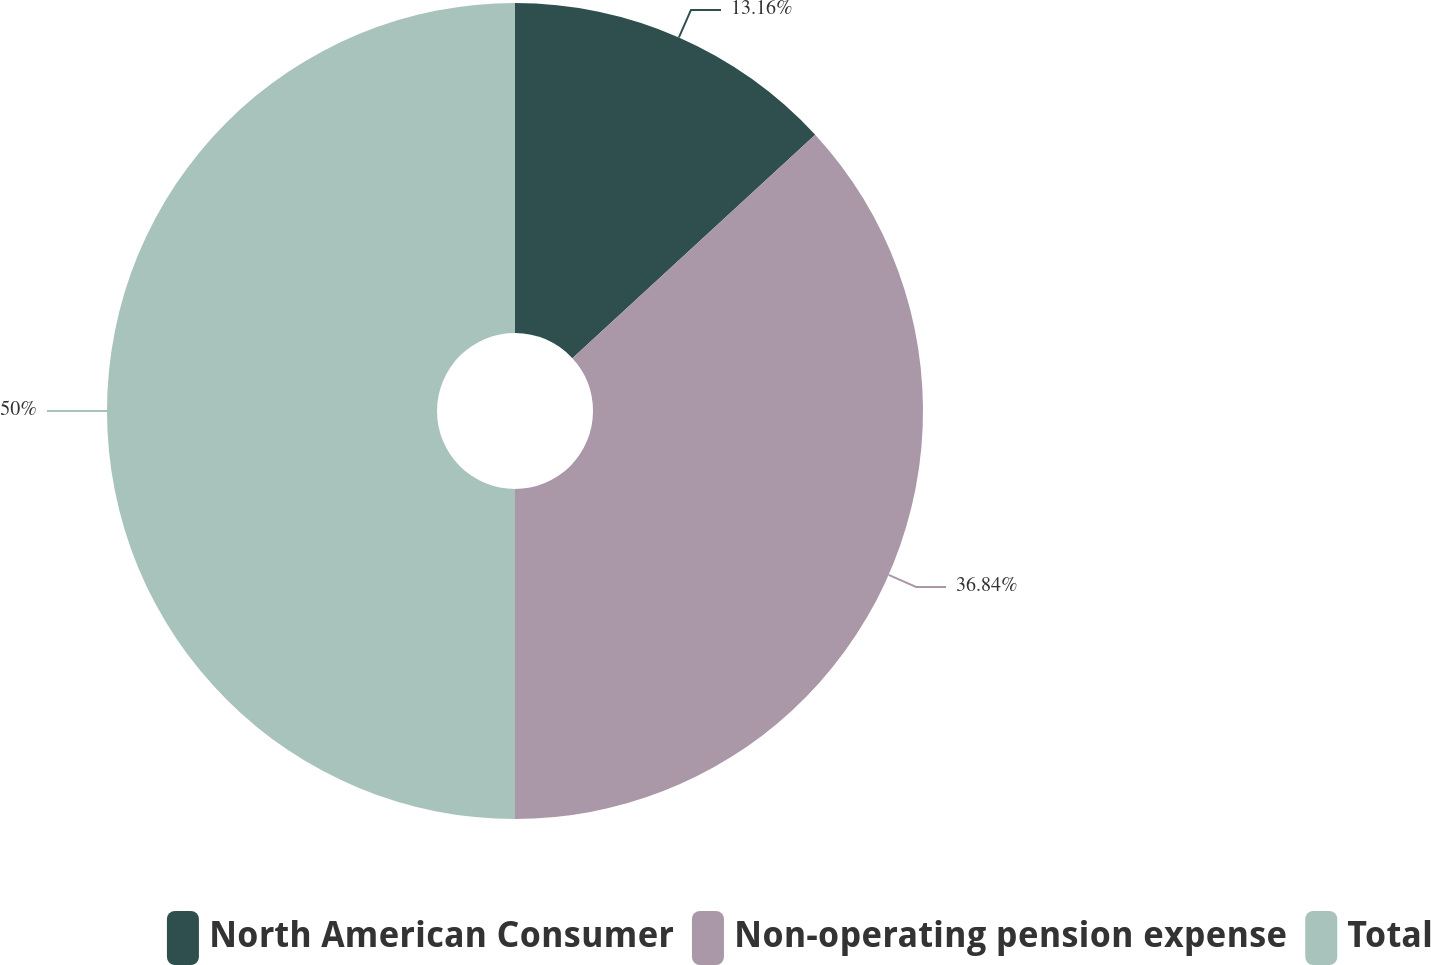Convert chart to OTSL. <chart><loc_0><loc_0><loc_500><loc_500><pie_chart><fcel>North American Consumer<fcel>Non-operating pension expense<fcel>Total<nl><fcel>13.16%<fcel>36.84%<fcel>50.0%<nl></chart> 